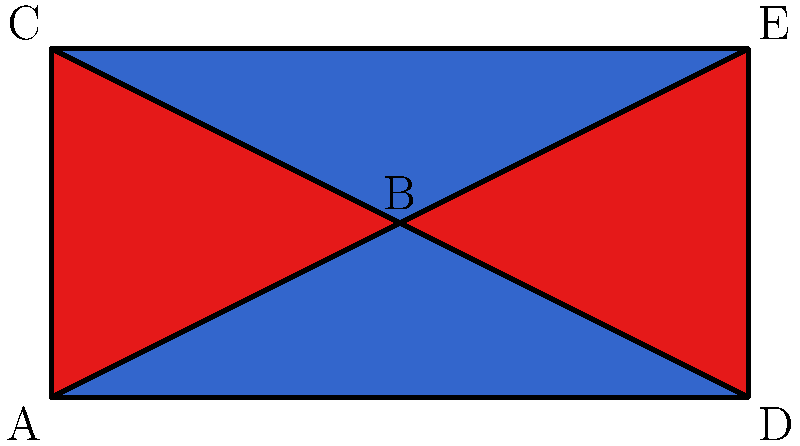In the flag design shown above, which pair of triangles are congruent? Explain your reasoning using the principles of triangle congruence. To determine if two triangles are congruent, we need to check if they satisfy one of the congruence criteria: SSS, SAS, ASA, or AAS. Let's analyze the triangles in the flag:

1. Triangle ABC and triangle DBE are the two triangles we need to compare.

2. We can observe that:
   a) AB = DE (half the width of the flag)
   b) BC = BE (height of the flag)
   c) AC = DE (diagonal of the flag)

3. This gives us three pairs of equal sides:
   AB ≅ DE
   BC ≅ BE
   AC ≅ DE

4. When three pairs of corresponding sides are equal, we can apply the SSS (Side-Side-Side) congruence criterion.

5. The SSS criterion states that if three sides of one triangle are equal to three sides of another triangle, then the triangles are congruent.

6. Therefore, triangle ABC is congruent to triangle DBE.

This congruence aligns with the symmetrical design of the flag, which is often valued in conservative symbolism for its representation of balance and tradition.
Answer: Triangle ABC ≅ Triangle DBE (by SSS) 